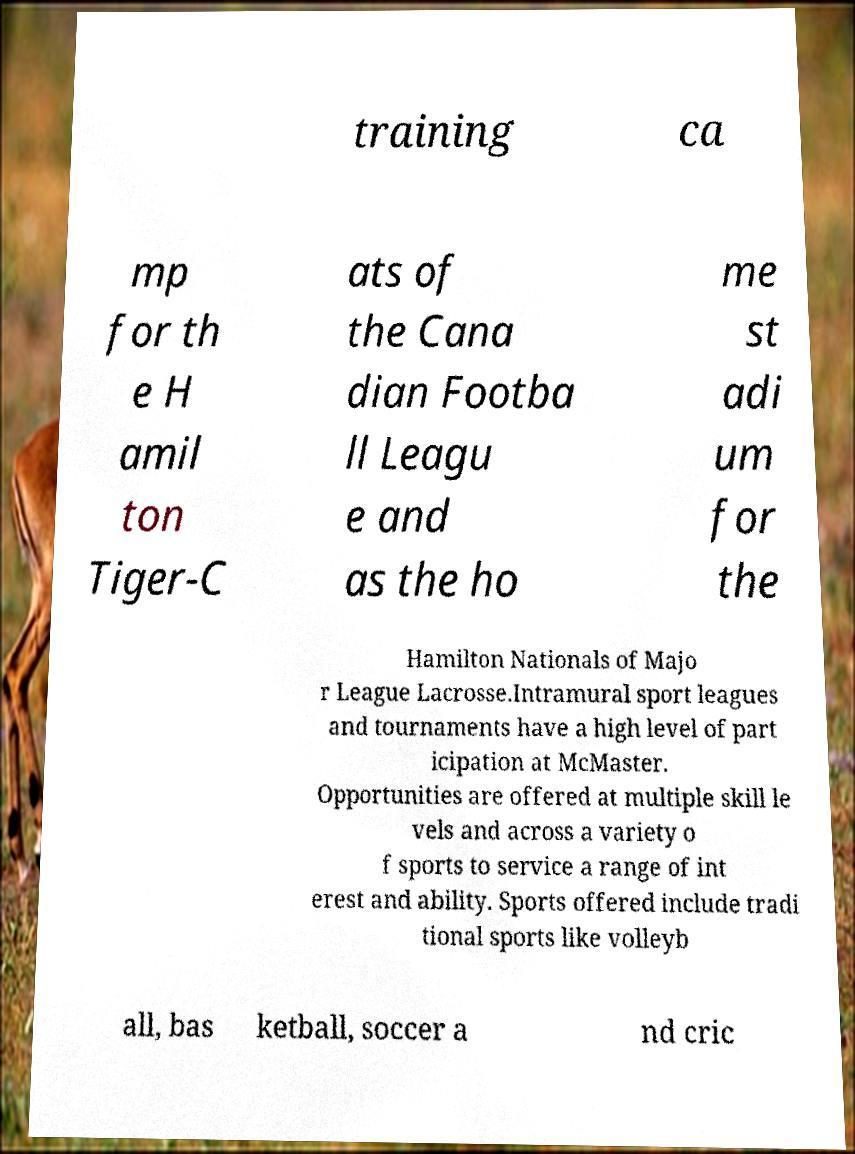What messages or text are displayed in this image? I need them in a readable, typed format. training ca mp for th e H amil ton Tiger-C ats of the Cana dian Footba ll Leagu e and as the ho me st adi um for the Hamilton Nationals of Majo r League Lacrosse.Intramural sport leagues and tournaments have a high level of part icipation at McMaster. Opportunities are offered at multiple skill le vels and across a variety o f sports to service a range of int erest and ability. Sports offered include tradi tional sports like volleyb all, bas ketball, soccer a nd cric 